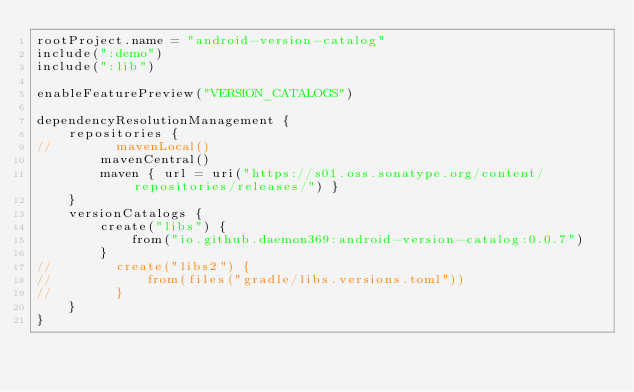Convert code to text. <code><loc_0><loc_0><loc_500><loc_500><_Kotlin_>rootProject.name = "android-version-catalog"
include(":demo")
include(":lib")

enableFeaturePreview("VERSION_CATALOGS")

dependencyResolutionManagement {
    repositories {
//        mavenLocal()
        mavenCentral()
        maven { url = uri("https://s01.oss.sonatype.org/content/repositories/releases/") }
    }
    versionCatalogs {
        create("libs") {
            from("io.github.daemon369:android-version-catalog:0.0.7")
        }
//        create("libs2") {
//            from(files("gradle/libs.versions.toml"))
//        }
    }
}</code> 